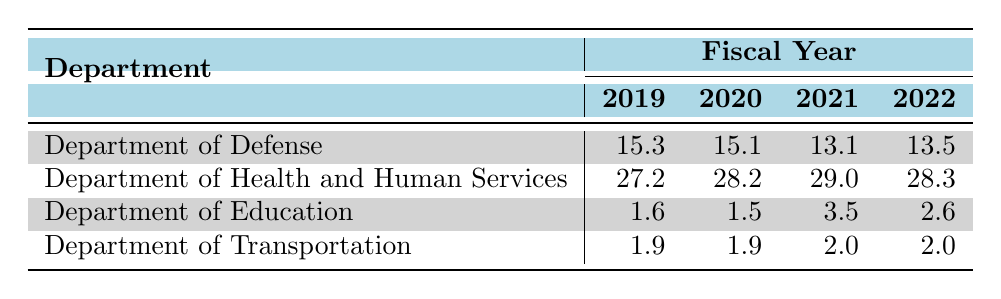What was the expenditure percentage for the Department of Health and Human Services in 2020? The table shows the percentages for each department across fiscal years. For the Department of Health and Human Services in 2020, the percentage is listed directly under the 2020 column.
Answer: 28.2 How much did the Department of Education's expenditure percentage change from 2019 to 2021? To find the change, we subtract the 2019 percentage from the 2021 percentage: 3.5 - 1.6 = 1.9. This shows the increase in the percentage over those two years.
Answer: 1.9 Was the expenditure percentage for the Department of Transportation consistent across the fiscal years? By looking at each year in the table, we see the percentage for the Department of Transportation is 1.9 for 2019, 1.9 for 2020, and then 2.0 for both 2021 and 2022. Since there was a slight change and not a consistent value, the answer is no.
Answer: No Which department had the highest expenditure percentage in 2021? We can find the highest percentage by comparing all the departments listed for 2021: Department of Defense (13.1), Health and Human Services (29.0), Education (3.5), and Transportation (2.0). The Department of Health and Human Services shows the highest value.
Answer: Department of Health and Human Services How much did the Department of Defense’s expenditure percentage drop from 2019 to 2021? To calculate the drop, subtract the 2021 percentage from the 2019 percentage: 15.3 - 13.1 = 2.2. This shows how much the percentage decreased over that period.
Answer: 2.2 